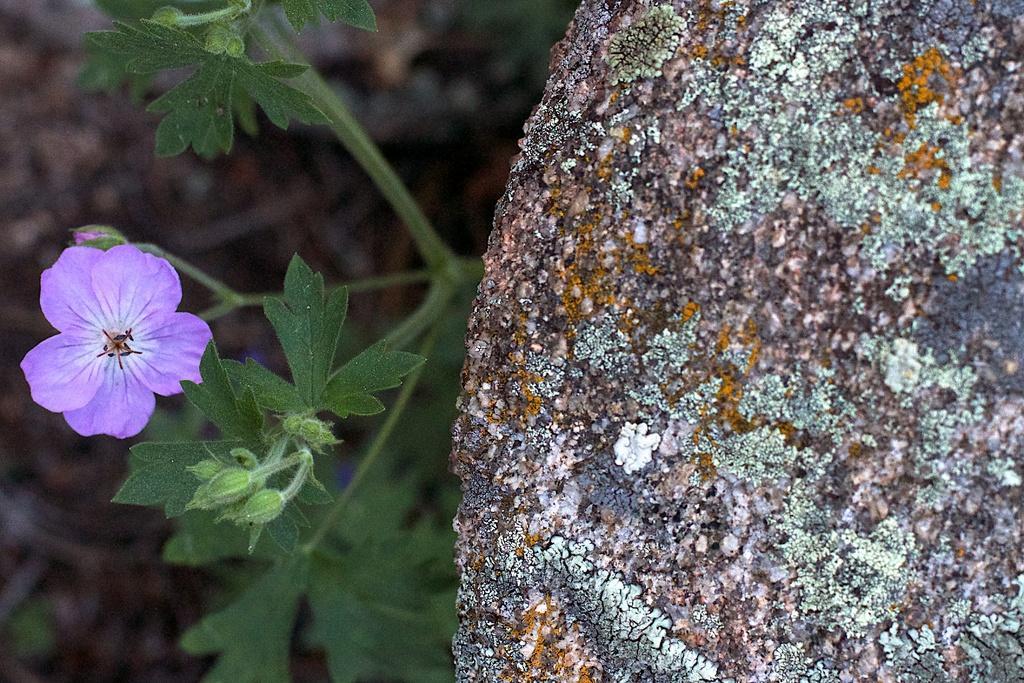Could you give a brief overview of what you see in this image? On the left side of the image we can see plant, buds, flower. On the right side of the image a rock is there. In the background the image is blur. 